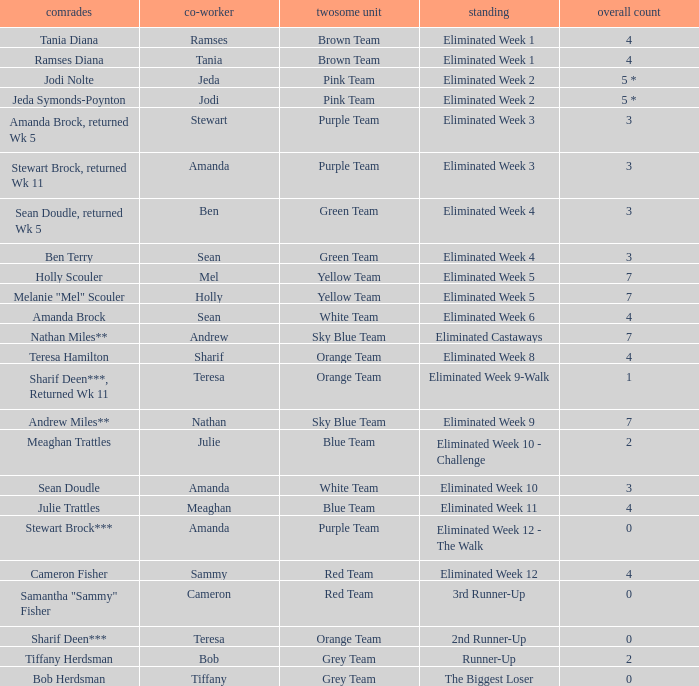Who had 0 total votes in the purple team? Eliminated Week 12 - The Walk. 